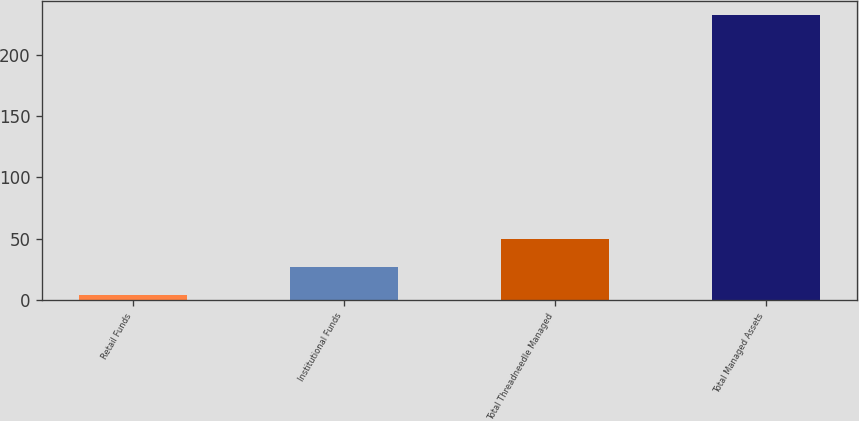Convert chart. <chart><loc_0><loc_0><loc_500><loc_500><bar_chart><fcel>Retail Funds<fcel>Institutional Funds<fcel>Total Threadneedle Managed<fcel>Total Managed Assets<nl><fcel>3.7<fcel>26.55<fcel>49.4<fcel>232.2<nl></chart> 